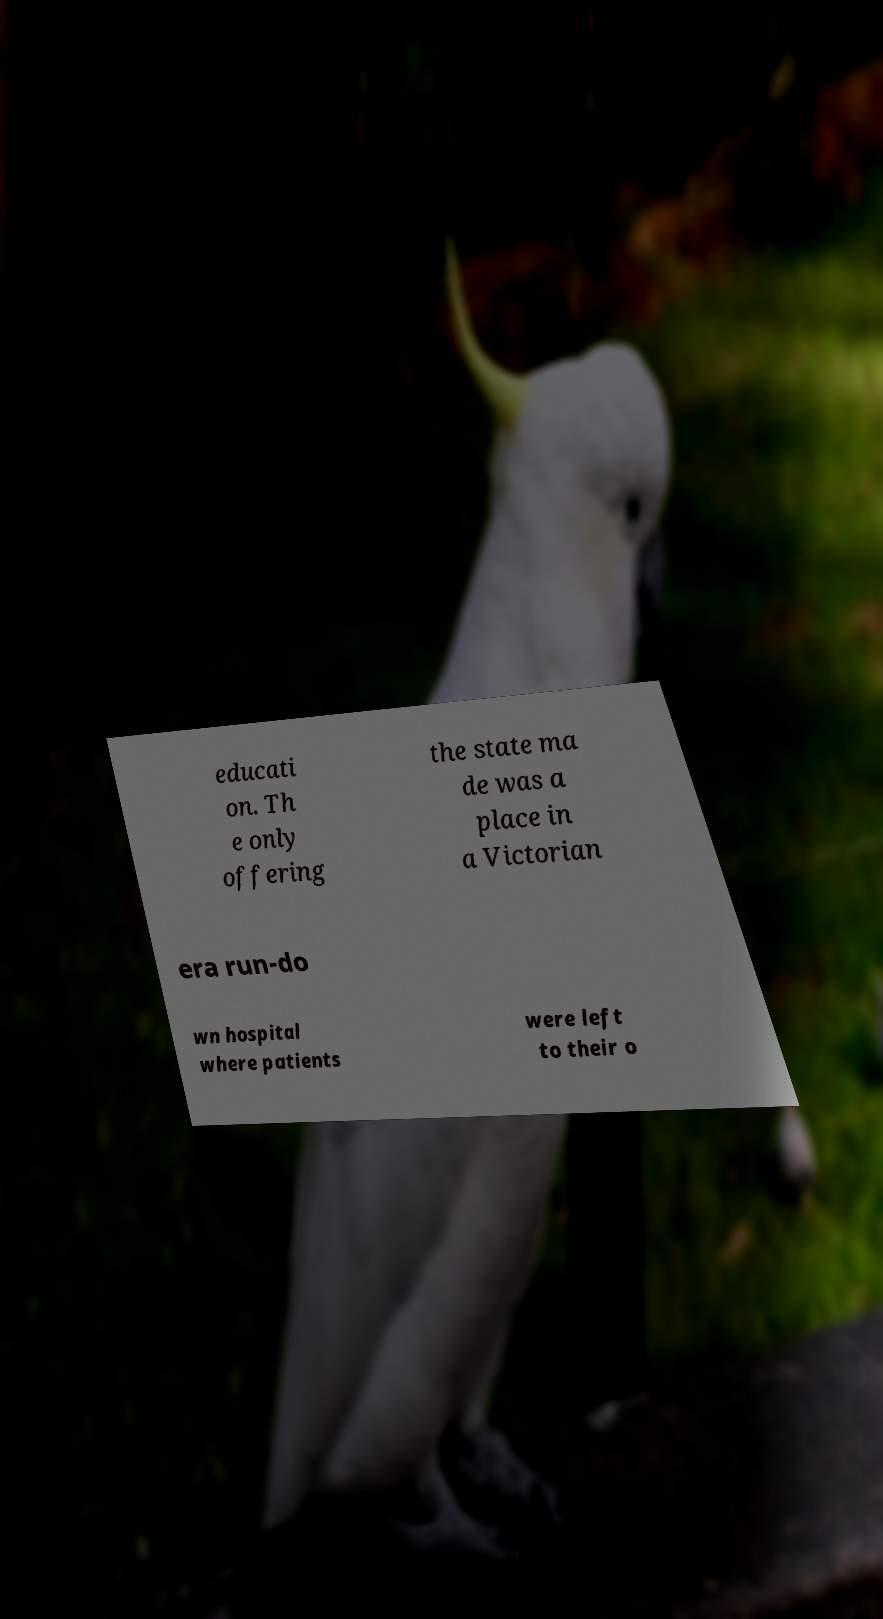What messages or text are displayed in this image? I need them in a readable, typed format. educati on. Th e only offering the state ma de was a place in a Victorian era run-do wn hospital where patients were left to their o 